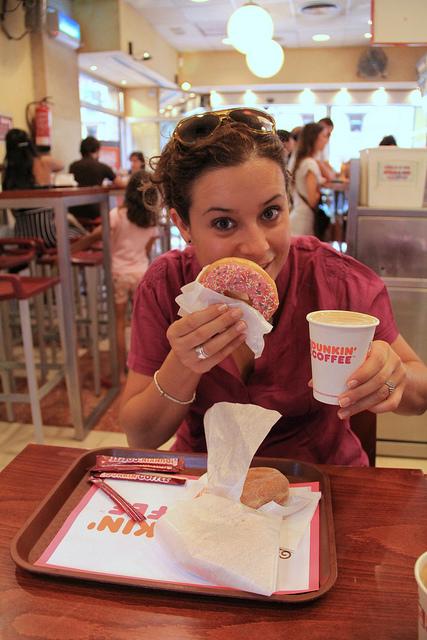What does she have on top of her head?
Be succinct. Sunglasses. What shop is she eating at?
Short answer required. Dunkin donuts. Are the lights on?
Keep it brief. Yes. 